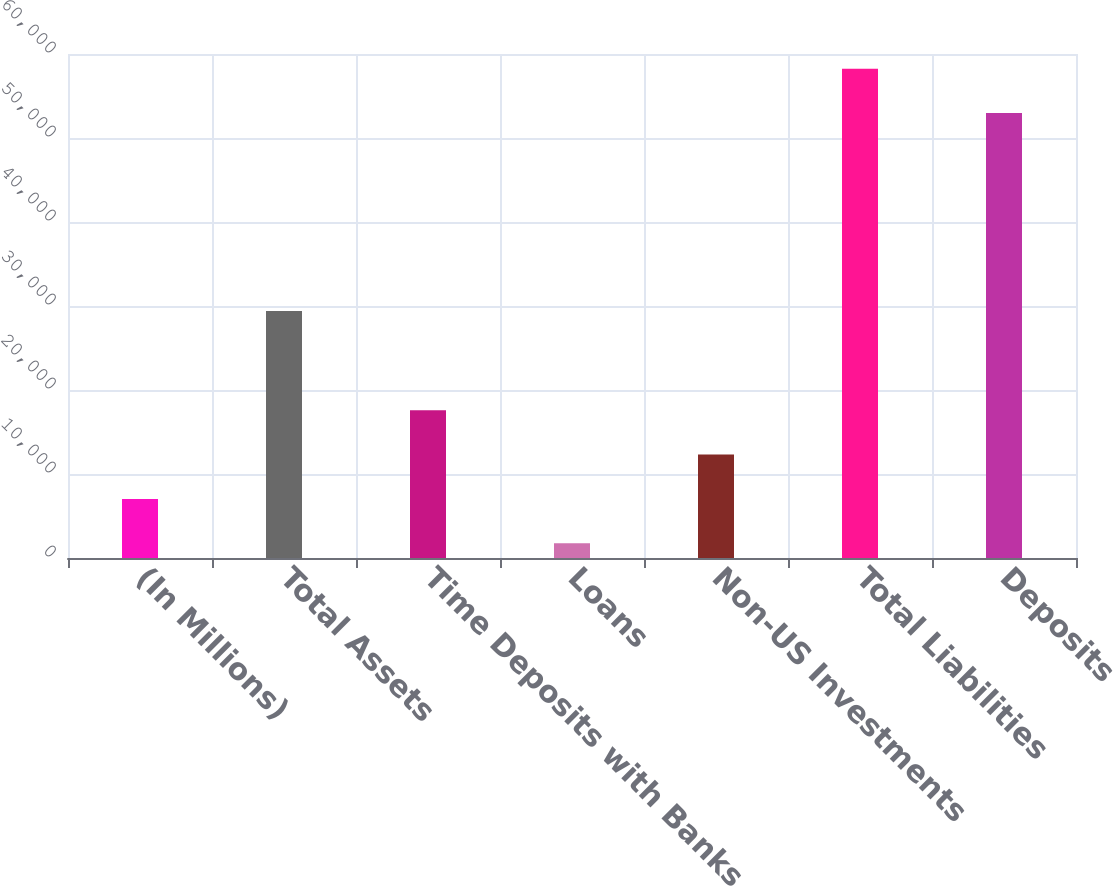Convert chart. <chart><loc_0><loc_0><loc_500><loc_500><bar_chart><fcel>(In Millions)<fcel>Total Assets<fcel>Time Deposits with Banks<fcel>Loans<fcel>Non-US Investments<fcel>Total Liabilities<fcel>Deposits<nl><fcel>7035.56<fcel>29411.2<fcel>17587.9<fcel>1759.4<fcel>12311.7<fcel>58257.4<fcel>52981.2<nl></chart> 